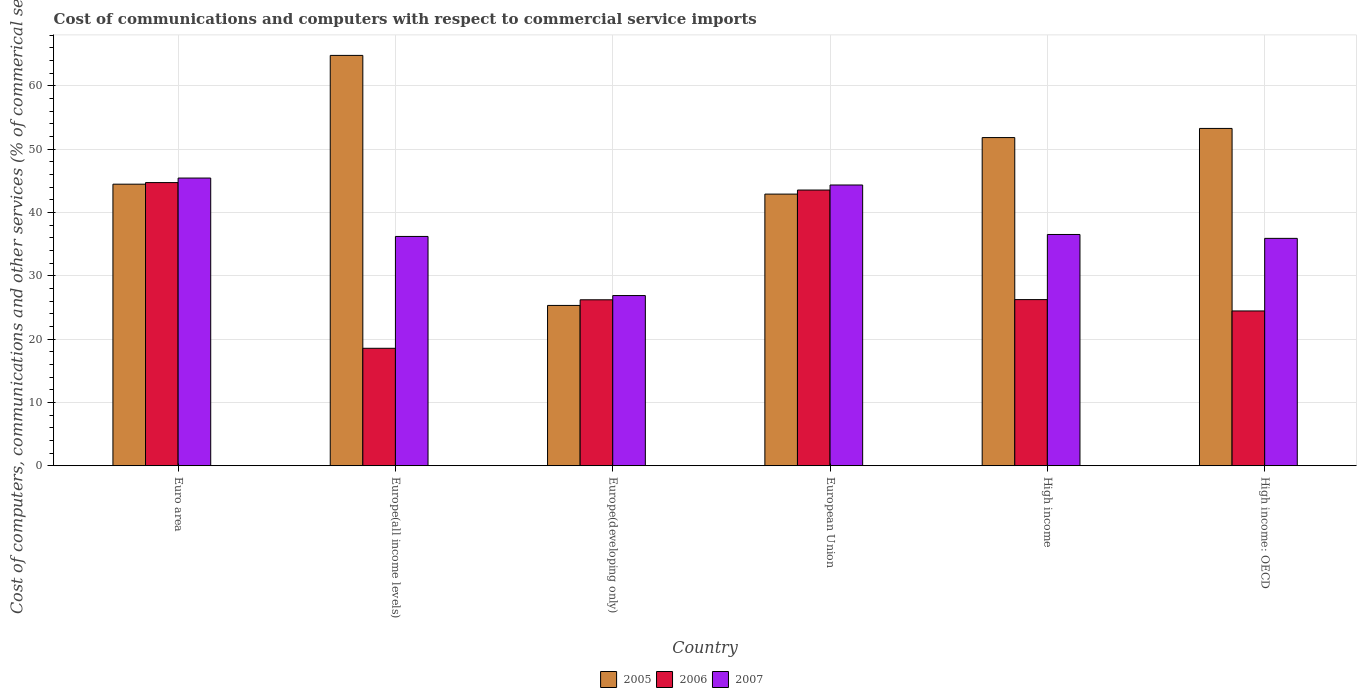How many different coloured bars are there?
Your response must be concise. 3. Are the number of bars per tick equal to the number of legend labels?
Keep it short and to the point. Yes. How many bars are there on the 4th tick from the right?
Your answer should be very brief. 3. What is the cost of communications and computers in 2007 in High income?
Your answer should be very brief. 36.52. Across all countries, what is the maximum cost of communications and computers in 2007?
Give a very brief answer. 45.43. Across all countries, what is the minimum cost of communications and computers in 2006?
Keep it short and to the point. 18.55. In which country was the cost of communications and computers in 2006 maximum?
Your response must be concise. Euro area. In which country was the cost of communications and computers in 2006 minimum?
Offer a very short reply. Europe(all income levels). What is the total cost of communications and computers in 2006 in the graph?
Provide a short and direct response. 183.7. What is the difference between the cost of communications and computers in 2006 in High income and that in High income: OECD?
Your response must be concise. 1.79. What is the difference between the cost of communications and computers in 2007 in Europe(developing only) and the cost of communications and computers in 2005 in Europe(all income levels)?
Keep it short and to the point. -37.93. What is the average cost of communications and computers in 2007 per country?
Provide a short and direct response. 37.55. What is the difference between the cost of communications and computers of/in 2007 and cost of communications and computers of/in 2005 in High income: OECD?
Provide a succinct answer. -17.36. What is the ratio of the cost of communications and computers in 2007 in Europe(all income levels) to that in High income?
Your answer should be compact. 0.99. Is the difference between the cost of communications and computers in 2007 in European Union and High income greater than the difference between the cost of communications and computers in 2005 in European Union and High income?
Provide a short and direct response. Yes. What is the difference between the highest and the second highest cost of communications and computers in 2007?
Offer a terse response. -1.1. What is the difference between the highest and the lowest cost of communications and computers in 2005?
Offer a terse response. 39.49. Is the sum of the cost of communications and computers in 2005 in Euro area and High income greater than the maximum cost of communications and computers in 2006 across all countries?
Offer a very short reply. Yes. What does the 2nd bar from the left in High income represents?
Keep it short and to the point. 2006. How many bars are there?
Your answer should be very brief. 18. Are all the bars in the graph horizontal?
Your answer should be very brief. No. How many countries are there in the graph?
Your answer should be very brief. 6. What is the difference between two consecutive major ticks on the Y-axis?
Your response must be concise. 10. Does the graph contain any zero values?
Offer a terse response. No. Does the graph contain grids?
Make the answer very short. Yes. Where does the legend appear in the graph?
Make the answer very short. Bottom center. How many legend labels are there?
Make the answer very short. 3. What is the title of the graph?
Offer a terse response. Cost of communications and computers with respect to commercial service imports. Does "1971" appear as one of the legend labels in the graph?
Provide a short and direct response. No. What is the label or title of the Y-axis?
Your response must be concise. Cost of computers, communications and other services (% of commerical service exports). What is the Cost of computers, communications and other services (% of commerical service exports) of 2005 in Euro area?
Offer a terse response. 44.47. What is the Cost of computers, communications and other services (% of commerical service exports) of 2006 in Euro area?
Keep it short and to the point. 44.72. What is the Cost of computers, communications and other services (% of commerical service exports) of 2007 in Euro area?
Provide a short and direct response. 45.43. What is the Cost of computers, communications and other services (% of commerical service exports) of 2005 in Europe(all income levels)?
Ensure brevity in your answer.  64.81. What is the Cost of computers, communications and other services (% of commerical service exports) of 2006 in Europe(all income levels)?
Provide a short and direct response. 18.55. What is the Cost of computers, communications and other services (% of commerical service exports) in 2007 in Europe(all income levels)?
Offer a very short reply. 36.21. What is the Cost of computers, communications and other services (% of commerical service exports) of 2005 in Europe(developing only)?
Offer a terse response. 25.32. What is the Cost of computers, communications and other services (% of commerical service exports) in 2006 in Europe(developing only)?
Keep it short and to the point. 26.21. What is the Cost of computers, communications and other services (% of commerical service exports) of 2007 in Europe(developing only)?
Make the answer very short. 26.88. What is the Cost of computers, communications and other services (% of commerical service exports) in 2005 in European Union?
Offer a terse response. 42.9. What is the Cost of computers, communications and other services (% of commerical service exports) in 2006 in European Union?
Your response must be concise. 43.54. What is the Cost of computers, communications and other services (% of commerical service exports) of 2007 in European Union?
Ensure brevity in your answer.  44.34. What is the Cost of computers, communications and other services (% of commerical service exports) of 2005 in High income?
Offer a terse response. 51.83. What is the Cost of computers, communications and other services (% of commerical service exports) of 2006 in High income?
Ensure brevity in your answer.  26.24. What is the Cost of computers, communications and other services (% of commerical service exports) in 2007 in High income?
Offer a terse response. 36.52. What is the Cost of computers, communications and other services (% of commerical service exports) of 2005 in High income: OECD?
Provide a short and direct response. 53.27. What is the Cost of computers, communications and other services (% of commerical service exports) in 2006 in High income: OECD?
Offer a very short reply. 24.45. What is the Cost of computers, communications and other services (% of commerical service exports) in 2007 in High income: OECD?
Your answer should be very brief. 35.91. Across all countries, what is the maximum Cost of computers, communications and other services (% of commerical service exports) in 2005?
Provide a short and direct response. 64.81. Across all countries, what is the maximum Cost of computers, communications and other services (% of commerical service exports) of 2006?
Provide a succinct answer. 44.72. Across all countries, what is the maximum Cost of computers, communications and other services (% of commerical service exports) in 2007?
Ensure brevity in your answer.  45.43. Across all countries, what is the minimum Cost of computers, communications and other services (% of commerical service exports) of 2005?
Provide a succinct answer. 25.32. Across all countries, what is the minimum Cost of computers, communications and other services (% of commerical service exports) of 2006?
Give a very brief answer. 18.55. Across all countries, what is the minimum Cost of computers, communications and other services (% of commerical service exports) of 2007?
Your answer should be compact. 26.88. What is the total Cost of computers, communications and other services (% of commerical service exports) of 2005 in the graph?
Offer a terse response. 282.59. What is the total Cost of computers, communications and other services (% of commerical service exports) of 2006 in the graph?
Provide a succinct answer. 183.7. What is the total Cost of computers, communications and other services (% of commerical service exports) in 2007 in the graph?
Your answer should be compact. 225.3. What is the difference between the Cost of computers, communications and other services (% of commerical service exports) of 2005 in Euro area and that in Europe(all income levels)?
Ensure brevity in your answer.  -20.34. What is the difference between the Cost of computers, communications and other services (% of commerical service exports) of 2006 in Euro area and that in Europe(all income levels)?
Offer a very short reply. 26.17. What is the difference between the Cost of computers, communications and other services (% of commerical service exports) of 2007 in Euro area and that in Europe(all income levels)?
Offer a very short reply. 9.22. What is the difference between the Cost of computers, communications and other services (% of commerical service exports) in 2005 in Euro area and that in Europe(developing only)?
Your response must be concise. 19.15. What is the difference between the Cost of computers, communications and other services (% of commerical service exports) in 2006 in Euro area and that in Europe(developing only)?
Provide a succinct answer. 18.51. What is the difference between the Cost of computers, communications and other services (% of commerical service exports) in 2007 in Euro area and that in Europe(developing only)?
Your answer should be very brief. 18.56. What is the difference between the Cost of computers, communications and other services (% of commerical service exports) of 2005 in Euro area and that in European Union?
Provide a short and direct response. 1.57. What is the difference between the Cost of computers, communications and other services (% of commerical service exports) in 2006 in Euro area and that in European Union?
Ensure brevity in your answer.  1.18. What is the difference between the Cost of computers, communications and other services (% of commerical service exports) of 2007 in Euro area and that in European Union?
Keep it short and to the point. 1.1. What is the difference between the Cost of computers, communications and other services (% of commerical service exports) in 2005 in Euro area and that in High income?
Your answer should be compact. -7.36. What is the difference between the Cost of computers, communications and other services (% of commerical service exports) of 2006 in Euro area and that in High income?
Give a very brief answer. 18.48. What is the difference between the Cost of computers, communications and other services (% of commerical service exports) in 2007 in Euro area and that in High income?
Your answer should be compact. 8.91. What is the difference between the Cost of computers, communications and other services (% of commerical service exports) in 2005 in Euro area and that in High income: OECD?
Offer a very short reply. -8.8. What is the difference between the Cost of computers, communications and other services (% of commerical service exports) in 2006 in Euro area and that in High income: OECD?
Give a very brief answer. 20.27. What is the difference between the Cost of computers, communications and other services (% of commerical service exports) in 2007 in Euro area and that in High income: OECD?
Offer a terse response. 9.53. What is the difference between the Cost of computers, communications and other services (% of commerical service exports) of 2005 in Europe(all income levels) and that in Europe(developing only)?
Your answer should be very brief. 39.49. What is the difference between the Cost of computers, communications and other services (% of commerical service exports) of 2006 in Europe(all income levels) and that in Europe(developing only)?
Offer a very short reply. -7.66. What is the difference between the Cost of computers, communications and other services (% of commerical service exports) of 2007 in Europe(all income levels) and that in Europe(developing only)?
Provide a succinct answer. 9.34. What is the difference between the Cost of computers, communications and other services (% of commerical service exports) of 2005 in Europe(all income levels) and that in European Union?
Your answer should be compact. 21.91. What is the difference between the Cost of computers, communications and other services (% of commerical service exports) of 2006 in Europe(all income levels) and that in European Union?
Your answer should be compact. -24.99. What is the difference between the Cost of computers, communications and other services (% of commerical service exports) in 2007 in Europe(all income levels) and that in European Union?
Make the answer very short. -8.12. What is the difference between the Cost of computers, communications and other services (% of commerical service exports) in 2005 in Europe(all income levels) and that in High income?
Provide a succinct answer. 12.98. What is the difference between the Cost of computers, communications and other services (% of commerical service exports) in 2006 in Europe(all income levels) and that in High income?
Your answer should be very brief. -7.69. What is the difference between the Cost of computers, communications and other services (% of commerical service exports) of 2007 in Europe(all income levels) and that in High income?
Offer a very short reply. -0.31. What is the difference between the Cost of computers, communications and other services (% of commerical service exports) of 2005 in Europe(all income levels) and that in High income: OECD?
Offer a terse response. 11.54. What is the difference between the Cost of computers, communications and other services (% of commerical service exports) in 2006 in Europe(all income levels) and that in High income: OECD?
Keep it short and to the point. -5.9. What is the difference between the Cost of computers, communications and other services (% of commerical service exports) in 2007 in Europe(all income levels) and that in High income: OECD?
Your response must be concise. 0.3. What is the difference between the Cost of computers, communications and other services (% of commerical service exports) of 2005 in Europe(developing only) and that in European Union?
Provide a succinct answer. -17.58. What is the difference between the Cost of computers, communications and other services (% of commerical service exports) of 2006 in Europe(developing only) and that in European Union?
Provide a succinct answer. -17.33. What is the difference between the Cost of computers, communications and other services (% of commerical service exports) in 2007 in Europe(developing only) and that in European Union?
Your answer should be very brief. -17.46. What is the difference between the Cost of computers, communications and other services (% of commerical service exports) in 2005 in Europe(developing only) and that in High income?
Offer a very short reply. -26.51. What is the difference between the Cost of computers, communications and other services (% of commerical service exports) in 2006 in Europe(developing only) and that in High income?
Keep it short and to the point. -0.03. What is the difference between the Cost of computers, communications and other services (% of commerical service exports) in 2007 in Europe(developing only) and that in High income?
Give a very brief answer. -9.65. What is the difference between the Cost of computers, communications and other services (% of commerical service exports) in 2005 in Europe(developing only) and that in High income: OECD?
Provide a short and direct response. -27.95. What is the difference between the Cost of computers, communications and other services (% of commerical service exports) of 2006 in Europe(developing only) and that in High income: OECD?
Your response must be concise. 1.76. What is the difference between the Cost of computers, communications and other services (% of commerical service exports) of 2007 in Europe(developing only) and that in High income: OECD?
Offer a terse response. -9.03. What is the difference between the Cost of computers, communications and other services (% of commerical service exports) in 2005 in European Union and that in High income?
Offer a very short reply. -8.93. What is the difference between the Cost of computers, communications and other services (% of commerical service exports) of 2006 in European Union and that in High income?
Your answer should be compact. 17.3. What is the difference between the Cost of computers, communications and other services (% of commerical service exports) in 2007 in European Union and that in High income?
Your answer should be very brief. 7.81. What is the difference between the Cost of computers, communications and other services (% of commerical service exports) of 2005 in European Union and that in High income: OECD?
Keep it short and to the point. -10.37. What is the difference between the Cost of computers, communications and other services (% of commerical service exports) in 2006 in European Union and that in High income: OECD?
Offer a terse response. 19.1. What is the difference between the Cost of computers, communications and other services (% of commerical service exports) in 2007 in European Union and that in High income: OECD?
Your answer should be compact. 8.43. What is the difference between the Cost of computers, communications and other services (% of commerical service exports) of 2005 in High income and that in High income: OECD?
Make the answer very short. -1.44. What is the difference between the Cost of computers, communications and other services (% of commerical service exports) of 2006 in High income and that in High income: OECD?
Keep it short and to the point. 1.79. What is the difference between the Cost of computers, communications and other services (% of commerical service exports) of 2007 in High income and that in High income: OECD?
Provide a short and direct response. 0.61. What is the difference between the Cost of computers, communications and other services (% of commerical service exports) of 2005 in Euro area and the Cost of computers, communications and other services (% of commerical service exports) of 2006 in Europe(all income levels)?
Your answer should be very brief. 25.92. What is the difference between the Cost of computers, communications and other services (% of commerical service exports) in 2005 in Euro area and the Cost of computers, communications and other services (% of commerical service exports) in 2007 in Europe(all income levels)?
Your response must be concise. 8.25. What is the difference between the Cost of computers, communications and other services (% of commerical service exports) in 2006 in Euro area and the Cost of computers, communications and other services (% of commerical service exports) in 2007 in Europe(all income levels)?
Your answer should be very brief. 8.51. What is the difference between the Cost of computers, communications and other services (% of commerical service exports) in 2005 in Euro area and the Cost of computers, communications and other services (% of commerical service exports) in 2006 in Europe(developing only)?
Your response must be concise. 18.26. What is the difference between the Cost of computers, communications and other services (% of commerical service exports) of 2005 in Euro area and the Cost of computers, communications and other services (% of commerical service exports) of 2007 in Europe(developing only)?
Your answer should be compact. 17.59. What is the difference between the Cost of computers, communications and other services (% of commerical service exports) in 2006 in Euro area and the Cost of computers, communications and other services (% of commerical service exports) in 2007 in Europe(developing only)?
Your answer should be very brief. 17.84. What is the difference between the Cost of computers, communications and other services (% of commerical service exports) in 2005 in Euro area and the Cost of computers, communications and other services (% of commerical service exports) in 2006 in European Union?
Your answer should be compact. 0.92. What is the difference between the Cost of computers, communications and other services (% of commerical service exports) of 2005 in Euro area and the Cost of computers, communications and other services (% of commerical service exports) of 2007 in European Union?
Your response must be concise. 0.13. What is the difference between the Cost of computers, communications and other services (% of commerical service exports) in 2006 in Euro area and the Cost of computers, communications and other services (% of commerical service exports) in 2007 in European Union?
Offer a terse response. 0.38. What is the difference between the Cost of computers, communications and other services (% of commerical service exports) in 2005 in Euro area and the Cost of computers, communications and other services (% of commerical service exports) in 2006 in High income?
Your response must be concise. 18.23. What is the difference between the Cost of computers, communications and other services (% of commerical service exports) in 2005 in Euro area and the Cost of computers, communications and other services (% of commerical service exports) in 2007 in High income?
Your answer should be compact. 7.94. What is the difference between the Cost of computers, communications and other services (% of commerical service exports) in 2006 in Euro area and the Cost of computers, communications and other services (% of commerical service exports) in 2007 in High income?
Ensure brevity in your answer.  8.2. What is the difference between the Cost of computers, communications and other services (% of commerical service exports) of 2005 in Euro area and the Cost of computers, communications and other services (% of commerical service exports) of 2006 in High income: OECD?
Your answer should be compact. 20.02. What is the difference between the Cost of computers, communications and other services (% of commerical service exports) of 2005 in Euro area and the Cost of computers, communications and other services (% of commerical service exports) of 2007 in High income: OECD?
Ensure brevity in your answer.  8.56. What is the difference between the Cost of computers, communications and other services (% of commerical service exports) in 2006 in Euro area and the Cost of computers, communications and other services (% of commerical service exports) in 2007 in High income: OECD?
Give a very brief answer. 8.81. What is the difference between the Cost of computers, communications and other services (% of commerical service exports) in 2005 in Europe(all income levels) and the Cost of computers, communications and other services (% of commerical service exports) in 2006 in Europe(developing only)?
Your answer should be very brief. 38.6. What is the difference between the Cost of computers, communications and other services (% of commerical service exports) of 2005 in Europe(all income levels) and the Cost of computers, communications and other services (% of commerical service exports) of 2007 in Europe(developing only)?
Provide a succinct answer. 37.93. What is the difference between the Cost of computers, communications and other services (% of commerical service exports) in 2006 in Europe(all income levels) and the Cost of computers, communications and other services (% of commerical service exports) in 2007 in Europe(developing only)?
Ensure brevity in your answer.  -8.33. What is the difference between the Cost of computers, communications and other services (% of commerical service exports) in 2005 in Europe(all income levels) and the Cost of computers, communications and other services (% of commerical service exports) in 2006 in European Union?
Make the answer very short. 21.27. What is the difference between the Cost of computers, communications and other services (% of commerical service exports) in 2005 in Europe(all income levels) and the Cost of computers, communications and other services (% of commerical service exports) in 2007 in European Union?
Keep it short and to the point. 20.47. What is the difference between the Cost of computers, communications and other services (% of commerical service exports) in 2006 in Europe(all income levels) and the Cost of computers, communications and other services (% of commerical service exports) in 2007 in European Union?
Provide a succinct answer. -25.79. What is the difference between the Cost of computers, communications and other services (% of commerical service exports) of 2005 in Europe(all income levels) and the Cost of computers, communications and other services (% of commerical service exports) of 2006 in High income?
Make the answer very short. 38.57. What is the difference between the Cost of computers, communications and other services (% of commerical service exports) in 2005 in Europe(all income levels) and the Cost of computers, communications and other services (% of commerical service exports) in 2007 in High income?
Your answer should be very brief. 28.28. What is the difference between the Cost of computers, communications and other services (% of commerical service exports) of 2006 in Europe(all income levels) and the Cost of computers, communications and other services (% of commerical service exports) of 2007 in High income?
Offer a terse response. -17.98. What is the difference between the Cost of computers, communications and other services (% of commerical service exports) of 2005 in Europe(all income levels) and the Cost of computers, communications and other services (% of commerical service exports) of 2006 in High income: OECD?
Your answer should be compact. 40.36. What is the difference between the Cost of computers, communications and other services (% of commerical service exports) of 2005 in Europe(all income levels) and the Cost of computers, communications and other services (% of commerical service exports) of 2007 in High income: OECD?
Provide a succinct answer. 28.9. What is the difference between the Cost of computers, communications and other services (% of commerical service exports) in 2006 in Europe(all income levels) and the Cost of computers, communications and other services (% of commerical service exports) in 2007 in High income: OECD?
Provide a succinct answer. -17.36. What is the difference between the Cost of computers, communications and other services (% of commerical service exports) in 2005 in Europe(developing only) and the Cost of computers, communications and other services (% of commerical service exports) in 2006 in European Union?
Your answer should be compact. -18.22. What is the difference between the Cost of computers, communications and other services (% of commerical service exports) of 2005 in Europe(developing only) and the Cost of computers, communications and other services (% of commerical service exports) of 2007 in European Union?
Your response must be concise. -19.02. What is the difference between the Cost of computers, communications and other services (% of commerical service exports) of 2006 in Europe(developing only) and the Cost of computers, communications and other services (% of commerical service exports) of 2007 in European Union?
Make the answer very short. -18.13. What is the difference between the Cost of computers, communications and other services (% of commerical service exports) in 2005 in Europe(developing only) and the Cost of computers, communications and other services (% of commerical service exports) in 2006 in High income?
Offer a very short reply. -0.92. What is the difference between the Cost of computers, communications and other services (% of commerical service exports) of 2005 in Europe(developing only) and the Cost of computers, communications and other services (% of commerical service exports) of 2007 in High income?
Offer a terse response. -11.21. What is the difference between the Cost of computers, communications and other services (% of commerical service exports) of 2006 in Europe(developing only) and the Cost of computers, communications and other services (% of commerical service exports) of 2007 in High income?
Offer a terse response. -10.31. What is the difference between the Cost of computers, communications and other services (% of commerical service exports) of 2005 in Europe(developing only) and the Cost of computers, communications and other services (% of commerical service exports) of 2006 in High income: OECD?
Offer a very short reply. 0.87. What is the difference between the Cost of computers, communications and other services (% of commerical service exports) of 2005 in Europe(developing only) and the Cost of computers, communications and other services (% of commerical service exports) of 2007 in High income: OECD?
Make the answer very short. -10.59. What is the difference between the Cost of computers, communications and other services (% of commerical service exports) of 2006 in Europe(developing only) and the Cost of computers, communications and other services (% of commerical service exports) of 2007 in High income: OECD?
Provide a short and direct response. -9.7. What is the difference between the Cost of computers, communications and other services (% of commerical service exports) of 2005 in European Union and the Cost of computers, communications and other services (% of commerical service exports) of 2006 in High income?
Keep it short and to the point. 16.66. What is the difference between the Cost of computers, communications and other services (% of commerical service exports) of 2005 in European Union and the Cost of computers, communications and other services (% of commerical service exports) of 2007 in High income?
Your answer should be compact. 6.38. What is the difference between the Cost of computers, communications and other services (% of commerical service exports) in 2006 in European Union and the Cost of computers, communications and other services (% of commerical service exports) in 2007 in High income?
Give a very brief answer. 7.02. What is the difference between the Cost of computers, communications and other services (% of commerical service exports) of 2005 in European Union and the Cost of computers, communications and other services (% of commerical service exports) of 2006 in High income: OECD?
Make the answer very short. 18.46. What is the difference between the Cost of computers, communications and other services (% of commerical service exports) of 2005 in European Union and the Cost of computers, communications and other services (% of commerical service exports) of 2007 in High income: OECD?
Offer a terse response. 6.99. What is the difference between the Cost of computers, communications and other services (% of commerical service exports) in 2006 in European Union and the Cost of computers, communications and other services (% of commerical service exports) in 2007 in High income: OECD?
Your answer should be compact. 7.63. What is the difference between the Cost of computers, communications and other services (% of commerical service exports) of 2005 in High income and the Cost of computers, communications and other services (% of commerical service exports) of 2006 in High income: OECD?
Offer a terse response. 27.38. What is the difference between the Cost of computers, communications and other services (% of commerical service exports) of 2005 in High income and the Cost of computers, communications and other services (% of commerical service exports) of 2007 in High income: OECD?
Your response must be concise. 15.92. What is the difference between the Cost of computers, communications and other services (% of commerical service exports) in 2006 in High income and the Cost of computers, communications and other services (% of commerical service exports) in 2007 in High income: OECD?
Give a very brief answer. -9.67. What is the average Cost of computers, communications and other services (% of commerical service exports) in 2005 per country?
Make the answer very short. 47.1. What is the average Cost of computers, communications and other services (% of commerical service exports) in 2006 per country?
Give a very brief answer. 30.62. What is the average Cost of computers, communications and other services (% of commerical service exports) of 2007 per country?
Your answer should be very brief. 37.55. What is the difference between the Cost of computers, communications and other services (% of commerical service exports) of 2005 and Cost of computers, communications and other services (% of commerical service exports) of 2006 in Euro area?
Make the answer very short. -0.25. What is the difference between the Cost of computers, communications and other services (% of commerical service exports) of 2005 and Cost of computers, communications and other services (% of commerical service exports) of 2007 in Euro area?
Ensure brevity in your answer.  -0.97. What is the difference between the Cost of computers, communications and other services (% of commerical service exports) of 2006 and Cost of computers, communications and other services (% of commerical service exports) of 2007 in Euro area?
Give a very brief answer. -0.71. What is the difference between the Cost of computers, communications and other services (% of commerical service exports) in 2005 and Cost of computers, communications and other services (% of commerical service exports) in 2006 in Europe(all income levels)?
Your answer should be very brief. 46.26. What is the difference between the Cost of computers, communications and other services (% of commerical service exports) of 2005 and Cost of computers, communications and other services (% of commerical service exports) of 2007 in Europe(all income levels)?
Provide a short and direct response. 28.59. What is the difference between the Cost of computers, communications and other services (% of commerical service exports) in 2006 and Cost of computers, communications and other services (% of commerical service exports) in 2007 in Europe(all income levels)?
Your answer should be compact. -17.67. What is the difference between the Cost of computers, communications and other services (% of commerical service exports) in 2005 and Cost of computers, communications and other services (% of commerical service exports) in 2006 in Europe(developing only)?
Make the answer very short. -0.89. What is the difference between the Cost of computers, communications and other services (% of commerical service exports) of 2005 and Cost of computers, communications and other services (% of commerical service exports) of 2007 in Europe(developing only)?
Make the answer very short. -1.56. What is the difference between the Cost of computers, communications and other services (% of commerical service exports) of 2006 and Cost of computers, communications and other services (% of commerical service exports) of 2007 in Europe(developing only)?
Ensure brevity in your answer.  -0.67. What is the difference between the Cost of computers, communications and other services (% of commerical service exports) in 2005 and Cost of computers, communications and other services (% of commerical service exports) in 2006 in European Union?
Give a very brief answer. -0.64. What is the difference between the Cost of computers, communications and other services (% of commerical service exports) in 2005 and Cost of computers, communications and other services (% of commerical service exports) in 2007 in European Union?
Your answer should be very brief. -1.44. What is the difference between the Cost of computers, communications and other services (% of commerical service exports) in 2006 and Cost of computers, communications and other services (% of commerical service exports) in 2007 in European Union?
Your response must be concise. -0.8. What is the difference between the Cost of computers, communications and other services (% of commerical service exports) in 2005 and Cost of computers, communications and other services (% of commerical service exports) in 2006 in High income?
Ensure brevity in your answer.  25.59. What is the difference between the Cost of computers, communications and other services (% of commerical service exports) of 2005 and Cost of computers, communications and other services (% of commerical service exports) of 2007 in High income?
Your response must be concise. 15.31. What is the difference between the Cost of computers, communications and other services (% of commerical service exports) of 2006 and Cost of computers, communications and other services (% of commerical service exports) of 2007 in High income?
Offer a terse response. -10.29. What is the difference between the Cost of computers, communications and other services (% of commerical service exports) in 2005 and Cost of computers, communications and other services (% of commerical service exports) in 2006 in High income: OECD?
Offer a terse response. 28.83. What is the difference between the Cost of computers, communications and other services (% of commerical service exports) in 2005 and Cost of computers, communications and other services (% of commerical service exports) in 2007 in High income: OECD?
Your answer should be compact. 17.36. What is the difference between the Cost of computers, communications and other services (% of commerical service exports) of 2006 and Cost of computers, communications and other services (% of commerical service exports) of 2007 in High income: OECD?
Your answer should be very brief. -11.46. What is the ratio of the Cost of computers, communications and other services (% of commerical service exports) in 2005 in Euro area to that in Europe(all income levels)?
Your answer should be compact. 0.69. What is the ratio of the Cost of computers, communications and other services (% of commerical service exports) in 2006 in Euro area to that in Europe(all income levels)?
Your response must be concise. 2.41. What is the ratio of the Cost of computers, communications and other services (% of commerical service exports) of 2007 in Euro area to that in Europe(all income levels)?
Make the answer very short. 1.25. What is the ratio of the Cost of computers, communications and other services (% of commerical service exports) in 2005 in Euro area to that in Europe(developing only)?
Your answer should be very brief. 1.76. What is the ratio of the Cost of computers, communications and other services (% of commerical service exports) in 2006 in Euro area to that in Europe(developing only)?
Provide a succinct answer. 1.71. What is the ratio of the Cost of computers, communications and other services (% of commerical service exports) in 2007 in Euro area to that in Europe(developing only)?
Ensure brevity in your answer.  1.69. What is the ratio of the Cost of computers, communications and other services (% of commerical service exports) in 2005 in Euro area to that in European Union?
Make the answer very short. 1.04. What is the ratio of the Cost of computers, communications and other services (% of commerical service exports) of 2007 in Euro area to that in European Union?
Make the answer very short. 1.02. What is the ratio of the Cost of computers, communications and other services (% of commerical service exports) of 2005 in Euro area to that in High income?
Keep it short and to the point. 0.86. What is the ratio of the Cost of computers, communications and other services (% of commerical service exports) of 2006 in Euro area to that in High income?
Your response must be concise. 1.7. What is the ratio of the Cost of computers, communications and other services (% of commerical service exports) in 2007 in Euro area to that in High income?
Make the answer very short. 1.24. What is the ratio of the Cost of computers, communications and other services (% of commerical service exports) of 2005 in Euro area to that in High income: OECD?
Ensure brevity in your answer.  0.83. What is the ratio of the Cost of computers, communications and other services (% of commerical service exports) of 2006 in Euro area to that in High income: OECD?
Provide a succinct answer. 1.83. What is the ratio of the Cost of computers, communications and other services (% of commerical service exports) of 2007 in Euro area to that in High income: OECD?
Keep it short and to the point. 1.27. What is the ratio of the Cost of computers, communications and other services (% of commerical service exports) in 2005 in Europe(all income levels) to that in Europe(developing only)?
Make the answer very short. 2.56. What is the ratio of the Cost of computers, communications and other services (% of commerical service exports) in 2006 in Europe(all income levels) to that in Europe(developing only)?
Your response must be concise. 0.71. What is the ratio of the Cost of computers, communications and other services (% of commerical service exports) in 2007 in Europe(all income levels) to that in Europe(developing only)?
Provide a short and direct response. 1.35. What is the ratio of the Cost of computers, communications and other services (% of commerical service exports) in 2005 in Europe(all income levels) to that in European Union?
Provide a short and direct response. 1.51. What is the ratio of the Cost of computers, communications and other services (% of commerical service exports) of 2006 in Europe(all income levels) to that in European Union?
Make the answer very short. 0.43. What is the ratio of the Cost of computers, communications and other services (% of commerical service exports) of 2007 in Europe(all income levels) to that in European Union?
Make the answer very short. 0.82. What is the ratio of the Cost of computers, communications and other services (% of commerical service exports) of 2005 in Europe(all income levels) to that in High income?
Offer a terse response. 1.25. What is the ratio of the Cost of computers, communications and other services (% of commerical service exports) in 2006 in Europe(all income levels) to that in High income?
Offer a terse response. 0.71. What is the ratio of the Cost of computers, communications and other services (% of commerical service exports) in 2007 in Europe(all income levels) to that in High income?
Ensure brevity in your answer.  0.99. What is the ratio of the Cost of computers, communications and other services (% of commerical service exports) of 2005 in Europe(all income levels) to that in High income: OECD?
Give a very brief answer. 1.22. What is the ratio of the Cost of computers, communications and other services (% of commerical service exports) of 2006 in Europe(all income levels) to that in High income: OECD?
Ensure brevity in your answer.  0.76. What is the ratio of the Cost of computers, communications and other services (% of commerical service exports) in 2007 in Europe(all income levels) to that in High income: OECD?
Give a very brief answer. 1.01. What is the ratio of the Cost of computers, communications and other services (% of commerical service exports) of 2005 in Europe(developing only) to that in European Union?
Your answer should be very brief. 0.59. What is the ratio of the Cost of computers, communications and other services (% of commerical service exports) of 2006 in Europe(developing only) to that in European Union?
Your response must be concise. 0.6. What is the ratio of the Cost of computers, communications and other services (% of commerical service exports) in 2007 in Europe(developing only) to that in European Union?
Give a very brief answer. 0.61. What is the ratio of the Cost of computers, communications and other services (% of commerical service exports) in 2005 in Europe(developing only) to that in High income?
Provide a short and direct response. 0.49. What is the ratio of the Cost of computers, communications and other services (% of commerical service exports) of 2006 in Europe(developing only) to that in High income?
Your answer should be very brief. 1. What is the ratio of the Cost of computers, communications and other services (% of commerical service exports) in 2007 in Europe(developing only) to that in High income?
Offer a terse response. 0.74. What is the ratio of the Cost of computers, communications and other services (% of commerical service exports) in 2005 in Europe(developing only) to that in High income: OECD?
Your answer should be compact. 0.48. What is the ratio of the Cost of computers, communications and other services (% of commerical service exports) of 2006 in Europe(developing only) to that in High income: OECD?
Provide a short and direct response. 1.07. What is the ratio of the Cost of computers, communications and other services (% of commerical service exports) in 2007 in Europe(developing only) to that in High income: OECD?
Your response must be concise. 0.75. What is the ratio of the Cost of computers, communications and other services (% of commerical service exports) in 2005 in European Union to that in High income?
Ensure brevity in your answer.  0.83. What is the ratio of the Cost of computers, communications and other services (% of commerical service exports) in 2006 in European Union to that in High income?
Your answer should be compact. 1.66. What is the ratio of the Cost of computers, communications and other services (% of commerical service exports) in 2007 in European Union to that in High income?
Give a very brief answer. 1.21. What is the ratio of the Cost of computers, communications and other services (% of commerical service exports) of 2005 in European Union to that in High income: OECD?
Offer a terse response. 0.81. What is the ratio of the Cost of computers, communications and other services (% of commerical service exports) in 2006 in European Union to that in High income: OECD?
Your answer should be very brief. 1.78. What is the ratio of the Cost of computers, communications and other services (% of commerical service exports) of 2007 in European Union to that in High income: OECD?
Make the answer very short. 1.23. What is the ratio of the Cost of computers, communications and other services (% of commerical service exports) in 2005 in High income to that in High income: OECD?
Provide a succinct answer. 0.97. What is the ratio of the Cost of computers, communications and other services (% of commerical service exports) in 2006 in High income to that in High income: OECD?
Keep it short and to the point. 1.07. What is the ratio of the Cost of computers, communications and other services (% of commerical service exports) of 2007 in High income to that in High income: OECD?
Ensure brevity in your answer.  1.02. What is the difference between the highest and the second highest Cost of computers, communications and other services (% of commerical service exports) in 2005?
Offer a very short reply. 11.54. What is the difference between the highest and the second highest Cost of computers, communications and other services (% of commerical service exports) in 2006?
Your response must be concise. 1.18. What is the difference between the highest and the second highest Cost of computers, communications and other services (% of commerical service exports) in 2007?
Your answer should be very brief. 1.1. What is the difference between the highest and the lowest Cost of computers, communications and other services (% of commerical service exports) in 2005?
Your answer should be compact. 39.49. What is the difference between the highest and the lowest Cost of computers, communications and other services (% of commerical service exports) in 2006?
Make the answer very short. 26.17. What is the difference between the highest and the lowest Cost of computers, communications and other services (% of commerical service exports) in 2007?
Ensure brevity in your answer.  18.56. 